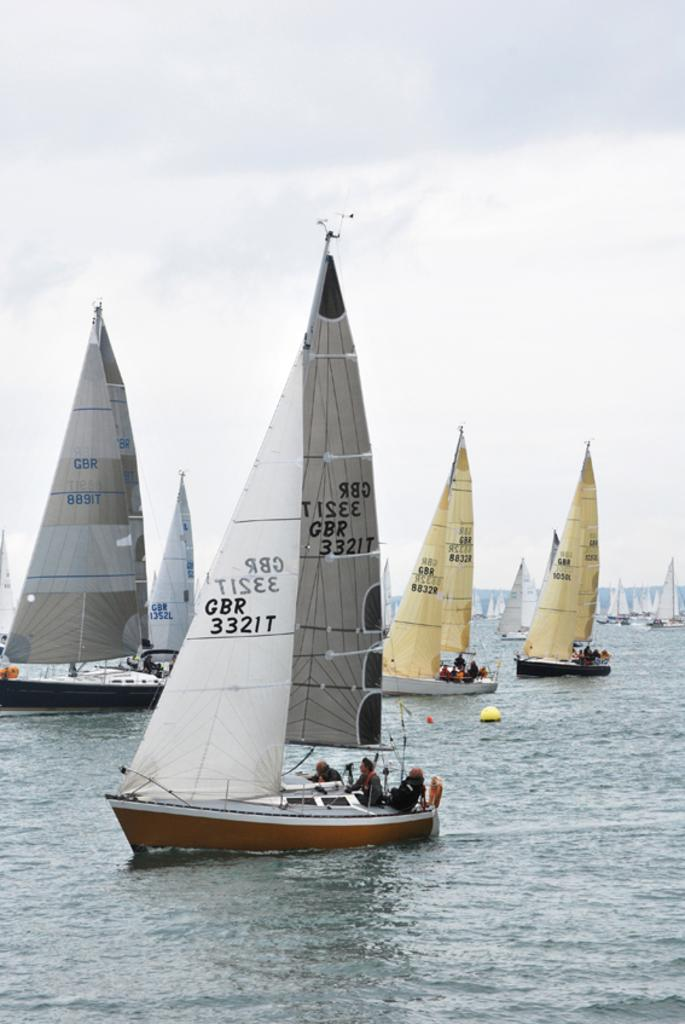<image>
Relay a brief, clear account of the picture shown. Many sailboats are in the water whose sails have GBR written on them. 